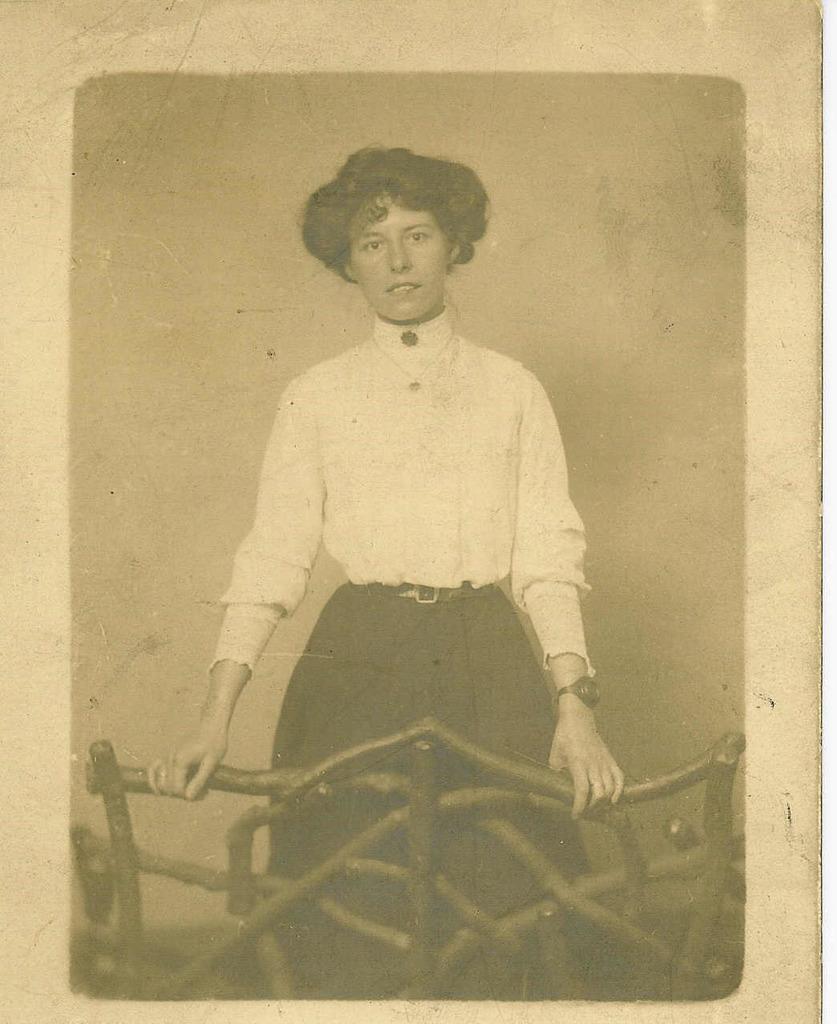Could you give a brief overview of what you see in this image? In this picture we can observe a woman, standing behind the railing. She is wearing a shirt and a skirt. This is a black and white image. 